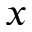Convert formula to latex. <formula><loc_0><loc_0><loc_500><loc_500>x</formula> 